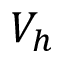<formula> <loc_0><loc_0><loc_500><loc_500>V _ { h }</formula> 